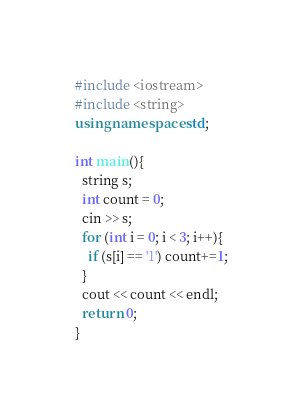Convert code to text. <code><loc_0><loc_0><loc_500><loc_500><_C++_>#include <iostream>
#include <string>
using namespace std;

int main(){
  string s;
  int count = 0;
  cin >> s;
  for (int i = 0; i < 3; i++){
    if (s[i] == '1') count+=1;
  }
  cout << count << endl;
  return 0;
}</code> 